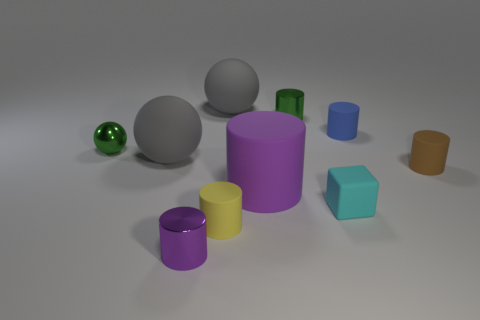Subtract all blocks. How many objects are left? 9 Subtract all gray spheres. How many spheres are left? 1 Subtract all tiny green cylinders. How many cylinders are left? 5 Subtract 1 cyan blocks. How many objects are left? 9 Subtract 2 cylinders. How many cylinders are left? 4 Subtract all brown spheres. Subtract all green cylinders. How many spheres are left? 3 Subtract all green cubes. How many gray balls are left? 2 Subtract all blue cylinders. Subtract all brown shiny cubes. How many objects are left? 9 Add 3 small cubes. How many small cubes are left? 4 Add 10 brown rubber blocks. How many brown rubber blocks exist? 10 